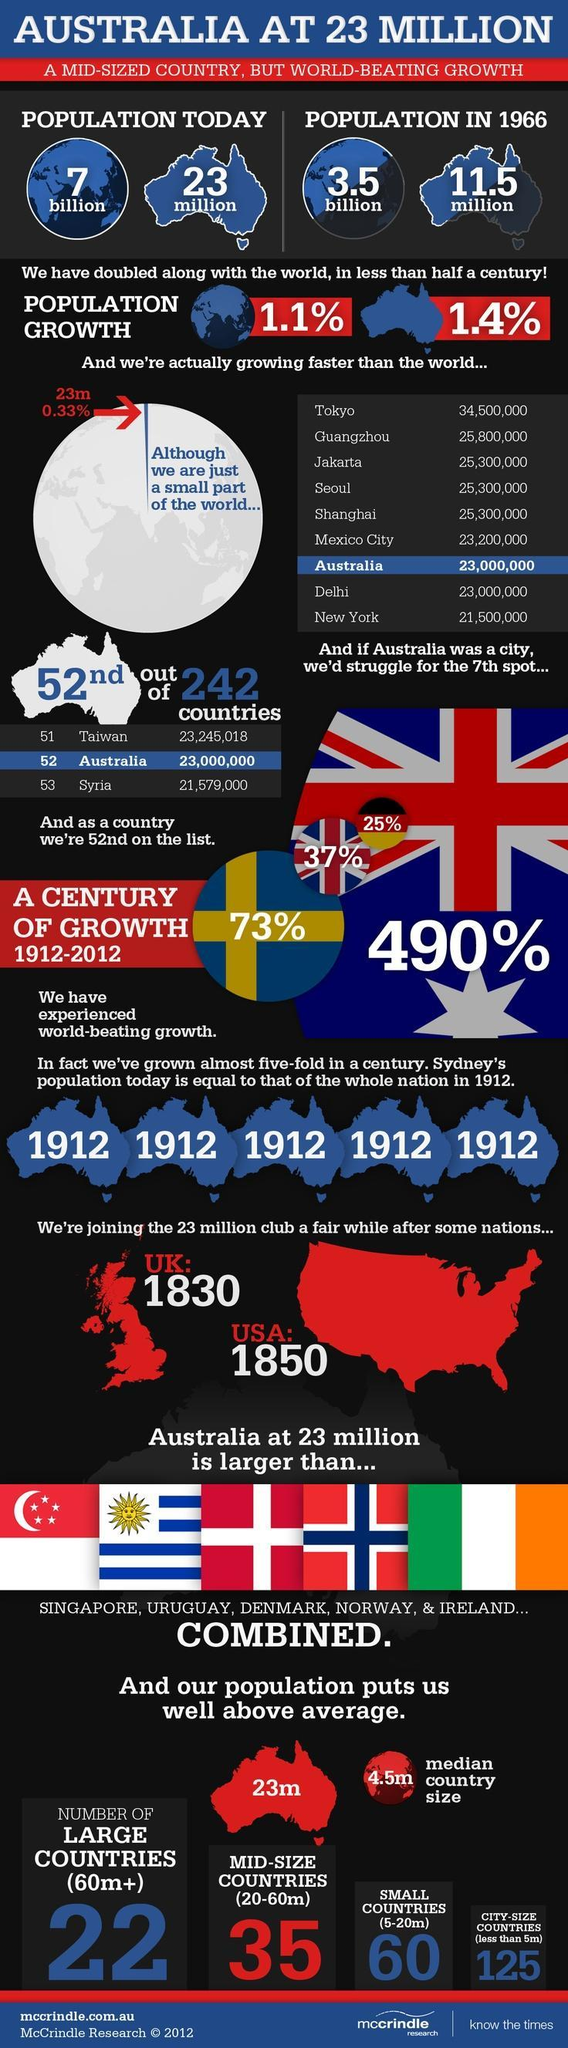What is the number of small countries with 5-20 million population?
Answer the question with a short phrase. 60 What is the population of the world in 1966? 3.5 billion What is the population of Australia in 1966? 11.5 million What is the number of mid size countries with 20-60 million population? 35 